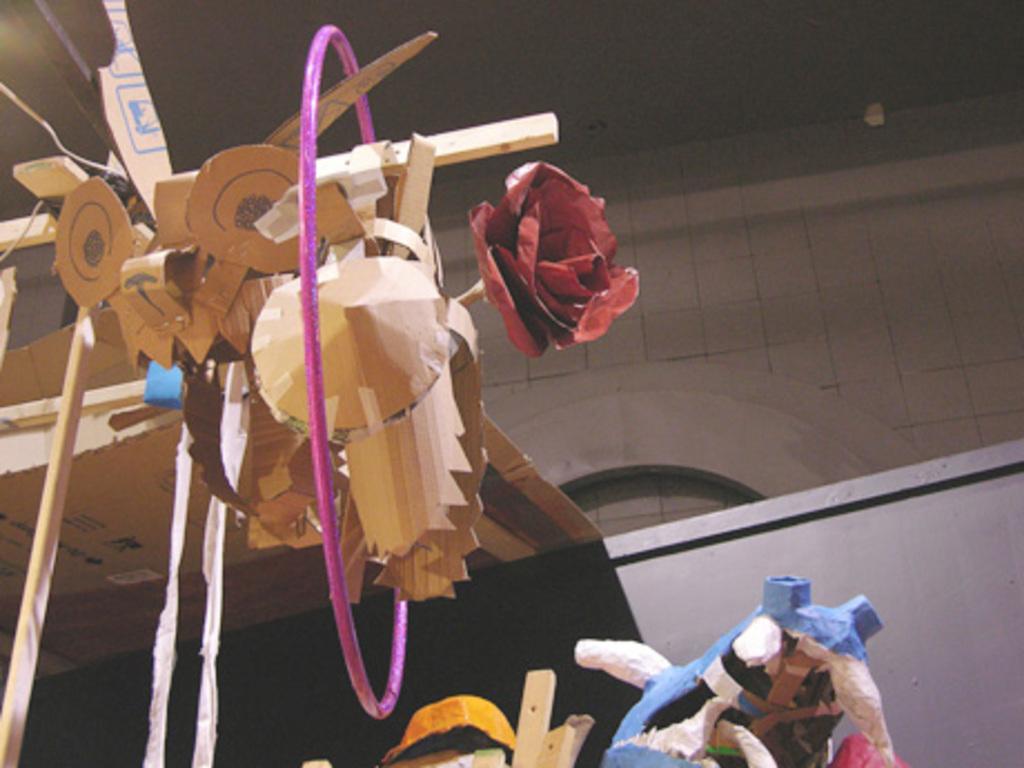Could you give a brief overview of what you see in this image? In this image we can see toys made with wood. In the background there is a wall. 